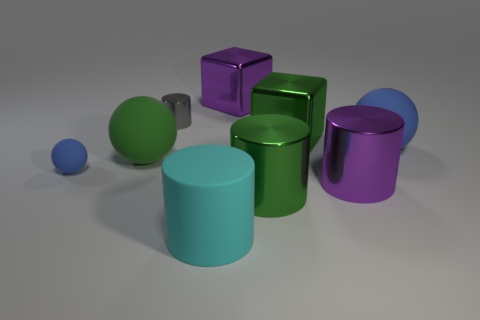How many objects are there, and can you describe their shapes? There are seven objects in total. Starting from the left, there's a small blue sphere, a medium-sized teal cylinder, a green cube, a lime green cylinder, a large purple cube, an olive green sphere, and a purple cylinder to the right. 